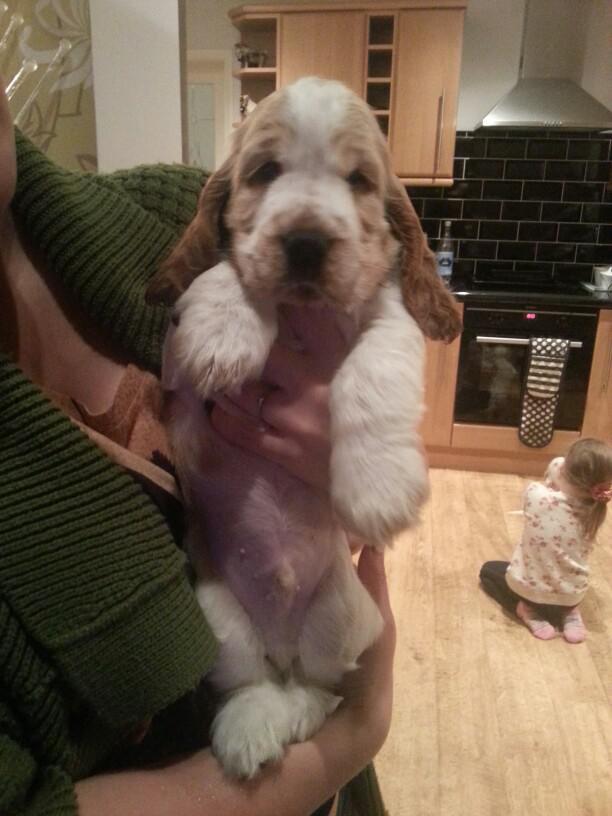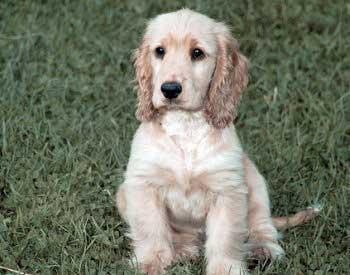The first image is the image on the left, the second image is the image on the right. Evaluate the accuracy of this statement regarding the images: "The dogs in all of the images are indoors.". Is it true? Answer yes or no. No. The first image is the image on the left, the second image is the image on the right. Evaluate the accuracy of this statement regarding the images: "The right image features at least one spaniel posed on green grass, and the left image contains just one spaniel, which is white with light orange markings.". Is it true? Answer yes or no. Yes. 